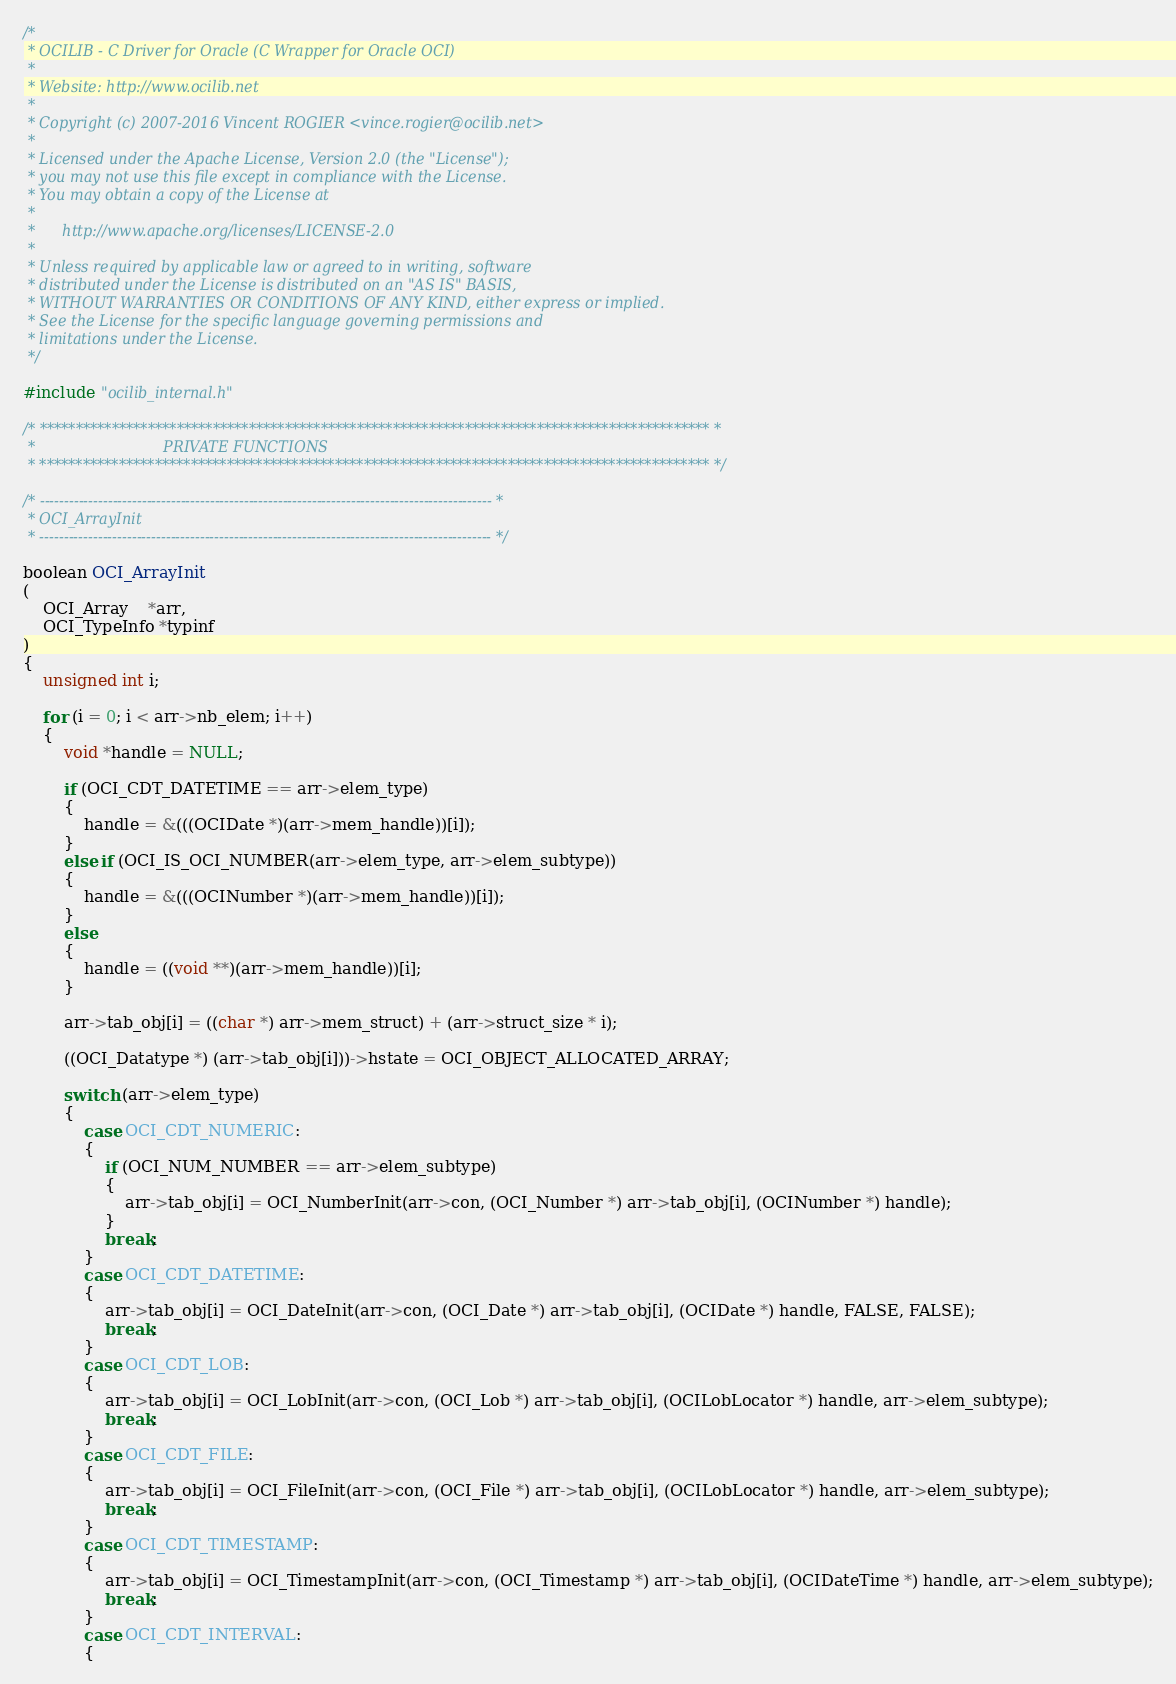Convert code to text. <code><loc_0><loc_0><loc_500><loc_500><_C_>/*
 * OCILIB - C Driver for Oracle (C Wrapper for Oracle OCI)
 *
 * Website: http://www.ocilib.net
 *
 * Copyright (c) 2007-2016 Vincent ROGIER <vince.rogier@ocilib.net>
 *
 * Licensed under the Apache License, Version 2.0 (the "License");
 * you may not use this file except in compliance with the License.
 * You may obtain a copy of the License at
 *
 *      http://www.apache.org/licenses/LICENSE-2.0
 *
 * Unless required by applicable law or agreed to in writing, software
 * distributed under the License is distributed on an "AS IS" BASIS,
 * WITHOUT WARRANTIES OR CONDITIONS OF ANY KIND, either express or implied.
 * See the License for the specific language governing permissions and
 * limitations under the License.
 */

#include "ocilib_internal.h"

/* ********************************************************************************************* *
 *                            PRIVATE FUNCTIONS
 * ********************************************************************************************* */

/* --------------------------------------------------------------------------------------------- *
 * OCI_ArrayInit
 * --------------------------------------------------------------------------------------------- */

boolean OCI_ArrayInit
(
    OCI_Array    *arr,
    OCI_TypeInfo *typinf
)
{
    unsigned int i;

    for (i = 0; i < arr->nb_elem; i++)
    {
        void *handle = NULL;

        if (OCI_CDT_DATETIME == arr->elem_type)
        {
            handle = &(((OCIDate *)(arr->mem_handle))[i]);
        }
        else if (OCI_IS_OCI_NUMBER(arr->elem_type, arr->elem_subtype))
        {
            handle = &(((OCINumber *)(arr->mem_handle))[i]);
        }
        else
        {
            handle = ((void **)(arr->mem_handle))[i];
        }

        arr->tab_obj[i] = ((char *) arr->mem_struct) + (arr->struct_size * i);

        ((OCI_Datatype *) (arr->tab_obj[i]))->hstate = OCI_OBJECT_ALLOCATED_ARRAY;

        switch (arr->elem_type)
        {
            case OCI_CDT_NUMERIC:
            {
                if (OCI_NUM_NUMBER == arr->elem_subtype)
                {
                    arr->tab_obj[i] = OCI_NumberInit(arr->con, (OCI_Number *) arr->tab_obj[i], (OCINumber *) handle);
                }
                break;
            }
            case OCI_CDT_DATETIME:
            {
                arr->tab_obj[i] = OCI_DateInit(arr->con, (OCI_Date *) arr->tab_obj[i], (OCIDate *) handle, FALSE, FALSE);
                break;
            }
            case OCI_CDT_LOB:
            {
                arr->tab_obj[i] = OCI_LobInit(arr->con, (OCI_Lob *) arr->tab_obj[i], (OCILobLocator *) handle, arr->elem_subtype);
                break;
            }
            case OCI_CDT_FILE:
            {
                arr->tab_obj[i] = OCI_FileInit(arr->con, (OCI_File *) arr->tab_obj[i], (OCILobLocator *) handle, arr->elem_subtype);
                break;
            }
            case OCI_CDT_TIMESTAMP:
            {
                arr->tab_obj[i] = OCI_TimestampInit(arr->con, (OCI_Timestamp *) arr->tab_obj[i], (OCIDateTime *) handle, arr->elem_subtype);
                break;
            }
            case OCI_CDT_INTERVAL:
            {</code> 